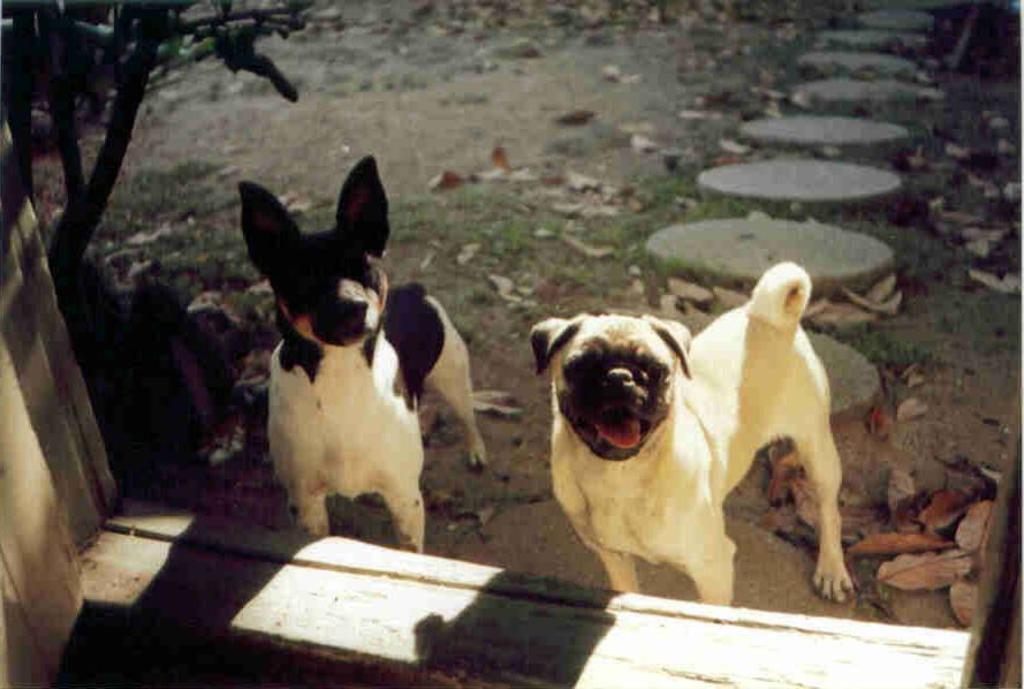What animals can be seen in the foreground of the image? There are two dogs in the foreground of the image. What is located on the left bottom of the image? There is a wall on the left bottom of the image. What can be seen in the background of the image? There is a tree, grassland, stones, and dried leaves in the background of the image. What type of cord is being used to control the flow of current in the image? There is no cord or current present in the image; it features two dogs, a wall, and various elements in the background. 